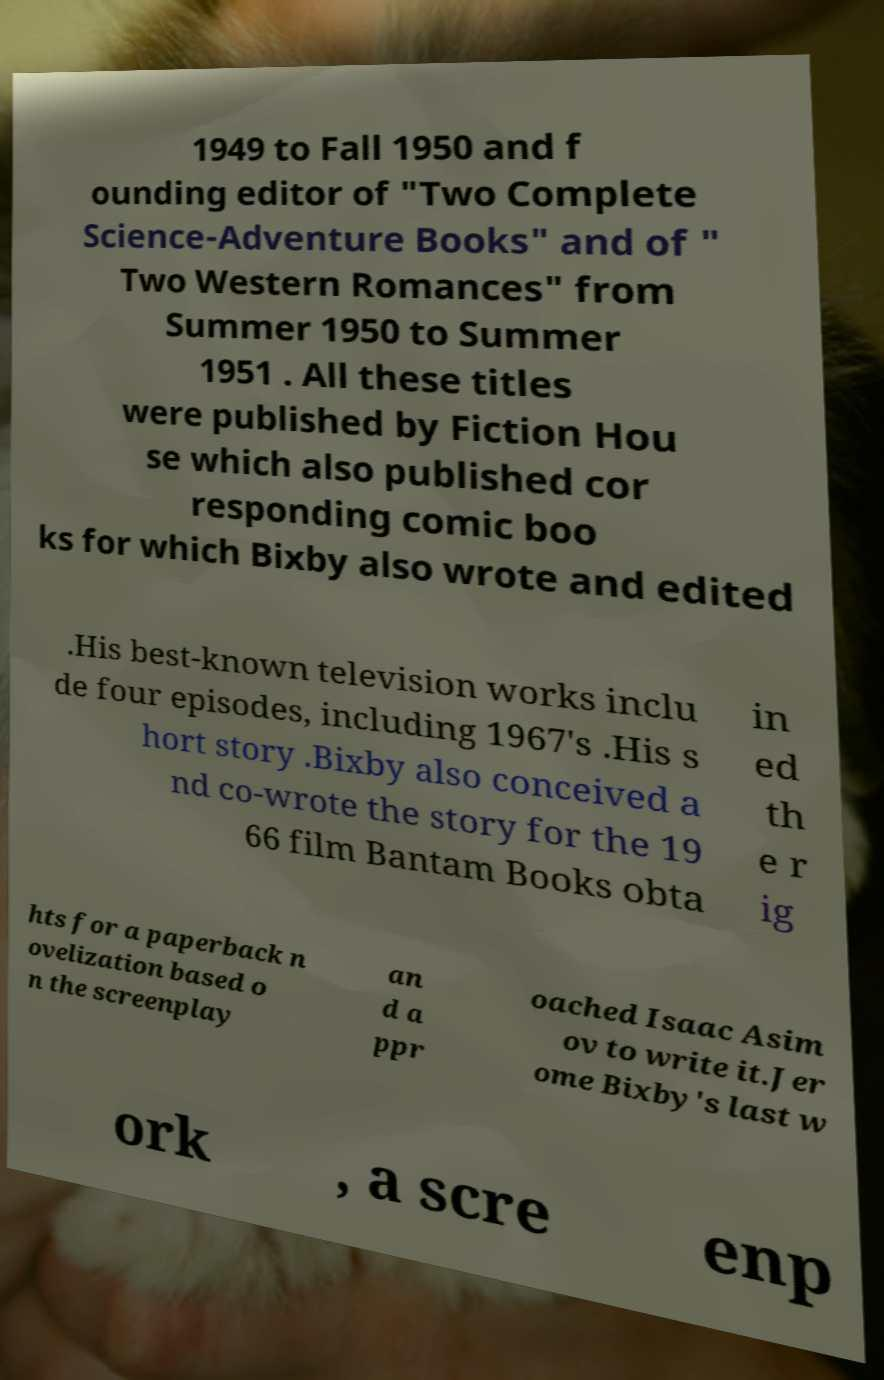Could you extract and type out the text from this image? 1949 to Fall 1950 and f ounding editor of "Two Complete Science-Adventure Books" and of " Two Western Romances" from Summer 1950 to Summer 1951 . All these titles were published by Fiction Hou se which also published cor responding comic boo ks for which Bixby also wrote and edited .His best-known television works inclu de four episodes, including 1967's .His s hort story .Bixby also conceived a nd co-wrote the story for the 19 66 film Bantam Books obta in ed th e r ig hts for a paperback n ovelization based o n the screenplay an d a ppr oached Isaac Asim ov to write it.Jer ome Bixby's last w ork , a scre enp 